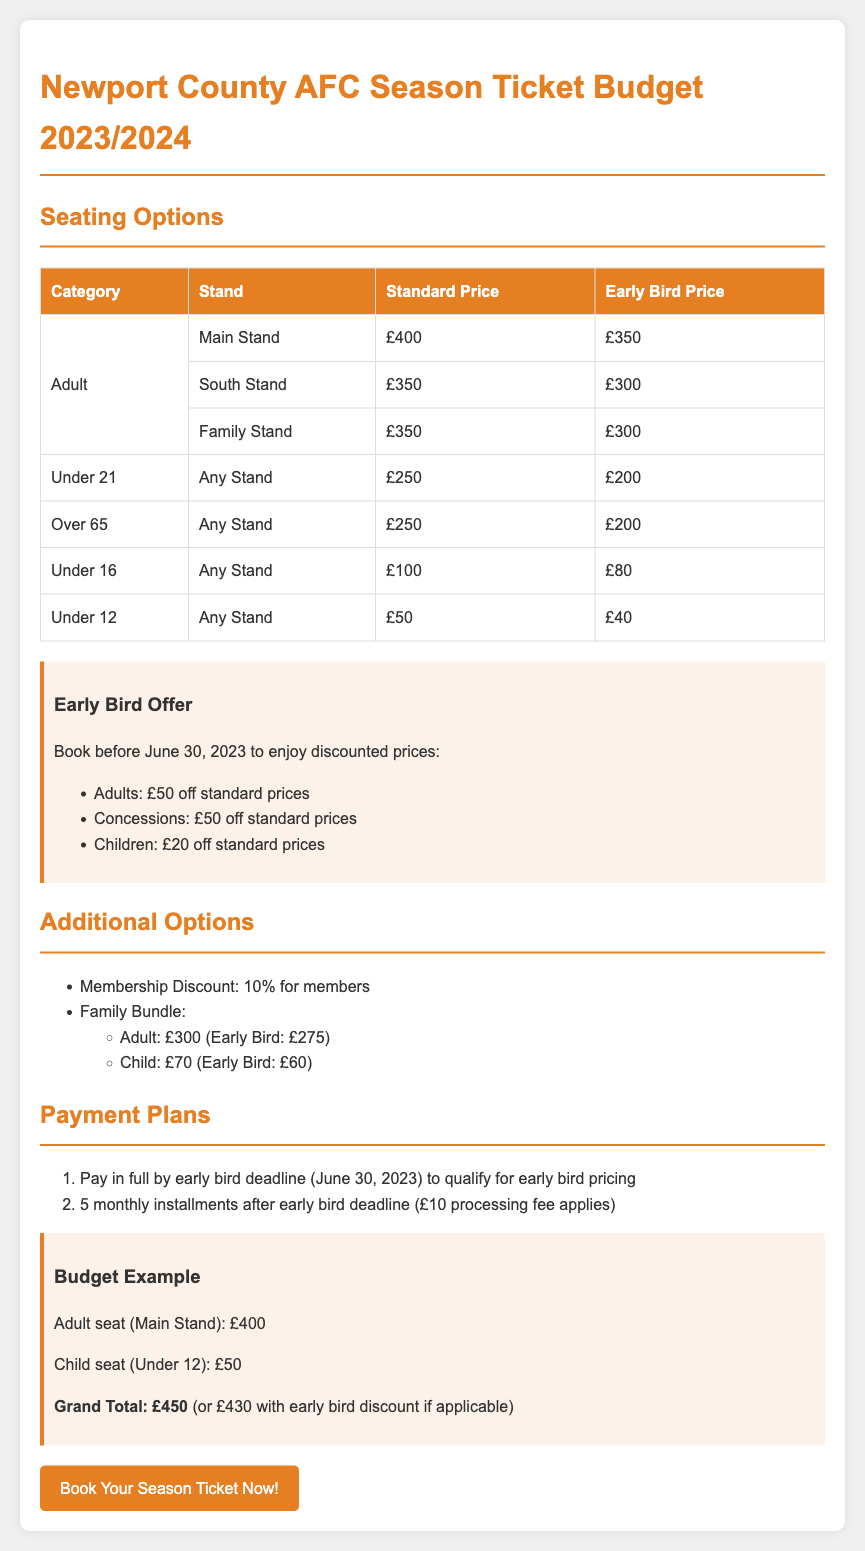What is the early bird price for an adult seat in the Main Stand? The early bird price for an adult seat in the Main Stand is listed as £350.
Answer: £350 How much is the discount for children under 12 during the early bird offer? The early bird offer states that children under 12 can enjoy a discount of £20 off standard prices.
Answer: £20 What is the standard price for a family stand seat for adults? The document specifies that the standard price for a family stand seat for adults is £350.
Answer: £350 What is the total cost for one adult seat in the Main Stand and one child seat under 12 with early bird pricing? The total cost is calculated by adding the early bird prices of £350 for the adult and £40 for the child seat, resulting in a grand total of £390.
Answer: £390 How many monthly installments are available if paying after the early bird deadline? The payment plan mentions that there are 5 monthly installments available after the early bird deadline.
Answer: 5 What percentage is the membership discount? The document indicates that the membership discount is 10%.
Answer: 10% What is the standard price for an under 21 seat? The standard price for an under 21 seat, applicable to any stand, is listed at £250.
Answer: £250 What is the last date to take advantage of the early bird prices? The early bird pricing must be booked before June 30, 2023, as stated in the document.
Answer: June 30, 2023 